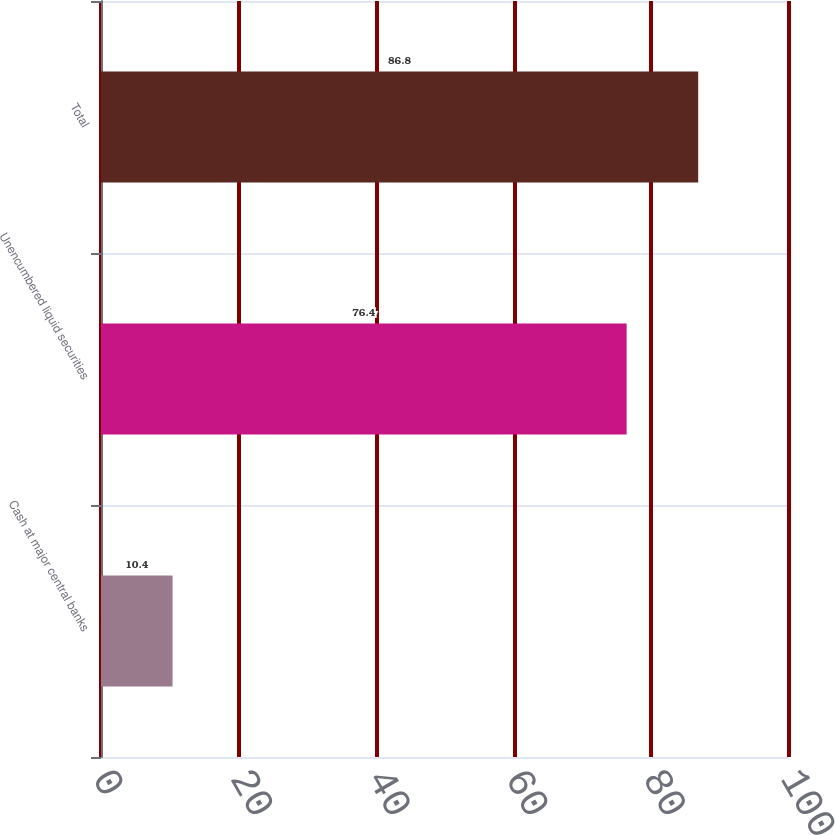<chart> <loc_0><loc_0><loc_500><loc_500><bar_chart><fcel>Cash at major central banks<fcel>Unencumbered liquid securities<fcel>Total<nl><fcel>10.4<fcel>76.4<fcel>86.8<nl></chart> 